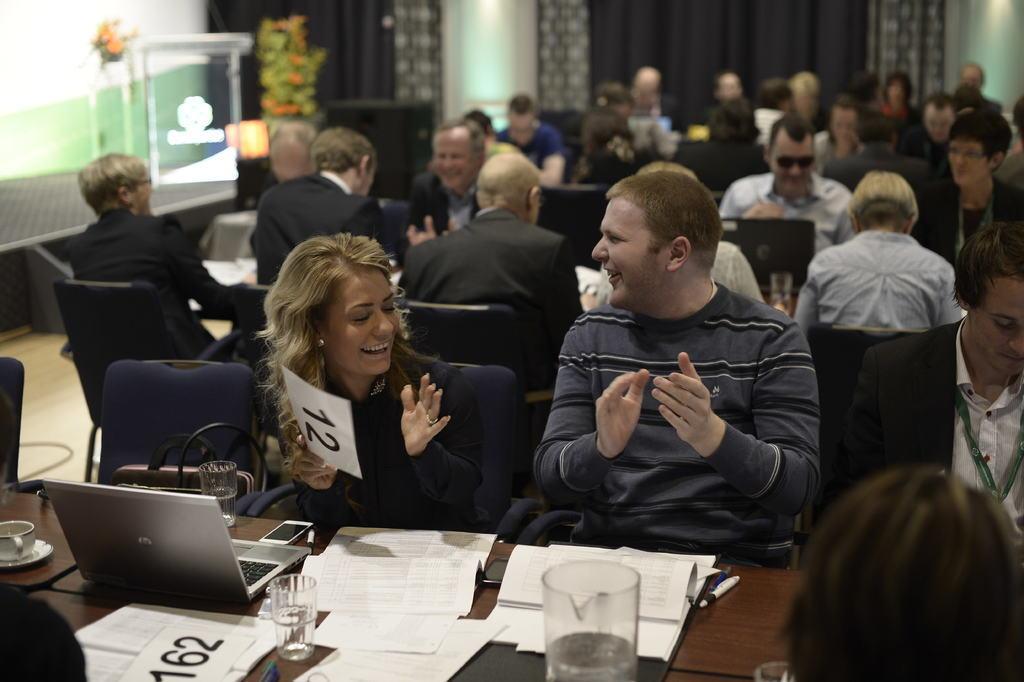In one or two sentences, can you explain what this image depicts? In the foreground of the image there is a table on which there are papers, glasses, laptop and other objects. In the background of the image there are people sitting in chairs. There is wall. There are plants. There is a podium. 